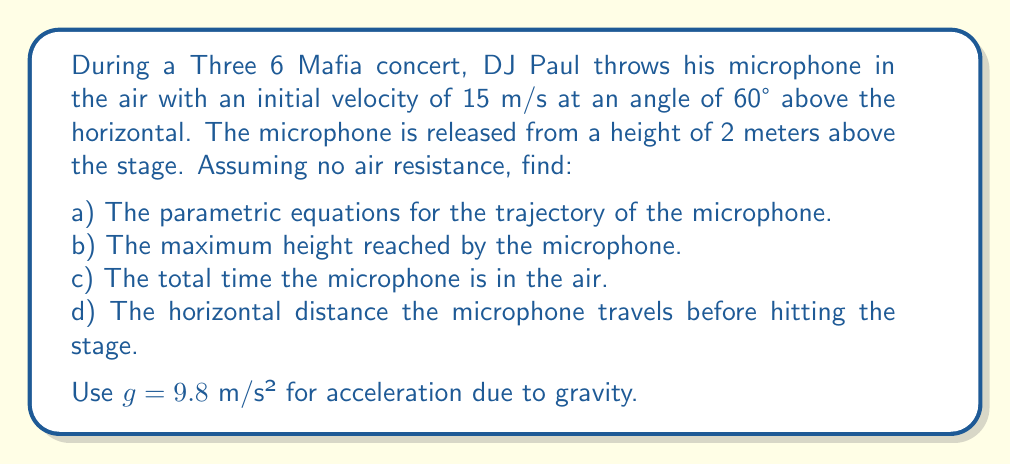Help me with this question. Let's approach this step-by-step:

1) First, let's establish our parametric equations. In parametric form, the position of the microphone at time $t$ is given by:

   $$x(t) = x_0 + v_0 \cos(\theta) t$$
   $$y(t) = y_0 + v_0 \sin(\theta) t - \frac{1}{2}gt^2$$

   Where $(x_0, y_0)$ is the initial position, $v_0$ is the initial velocity, $\theta$ is the angle of launch, and $g$ is the acceleration due to gravity.

2) Given information:
   $x_0 = 0$ m (assuming the throw starts at the origin)
   $y_0 = 2$ m
   $v_0 = 15$ m/s
   $\theta = 60°$
   $g = 9.8$ m/s²

3) Substituting these values:

   $$x(t) = (15 \cos(60°))t = 7.5t$$
   $$y(t) = 2 + (15 \sin(60°))t - \frac{1}{2}(9.8)t^2 = 2 + 13t - 4.9t^2$$

4) To find the maximum height, we need to find when the vertical velocity is zero:
   $$\frac{dy}{dt} = 13 - 9.8t = 0$$
   $$t = \frac{13}{9.8} \approx 1.33 \text{ s}$$

   Substituting this back into $y(t)$:
   $$y_{max} = 2 + 13(1.33) - 4.9(1.33)^2 \approx 10.63 \text{ m}$$

5) To find the total time in the air, we need to solve when $y(t) = 0$:
   $$2 + 13t - 4.9t^2 = 0$$
   $$4.9t^2 - 13t - 2 = 0$$

   Using the quadratic formula:
   $$t = \frac{13 \pm \sqrt{13^2 + 4(4.9)(2)}}{2(4.9)} \approx 2.88 \text{ s}$$

6) The horizontal distance is found by plugging this time into $x(t)$:
   $$x = 7.5(2.88) \approx 21.6 \text{ m}$$
Answer: a) $x(t) = 7.5t$, $y(t) = 2 + 13t - 4.9t^2$
b) Maximum height: 10.63 m
c) Total time in air: 2.88 s
d) Horizontal distance: 21.6 m 